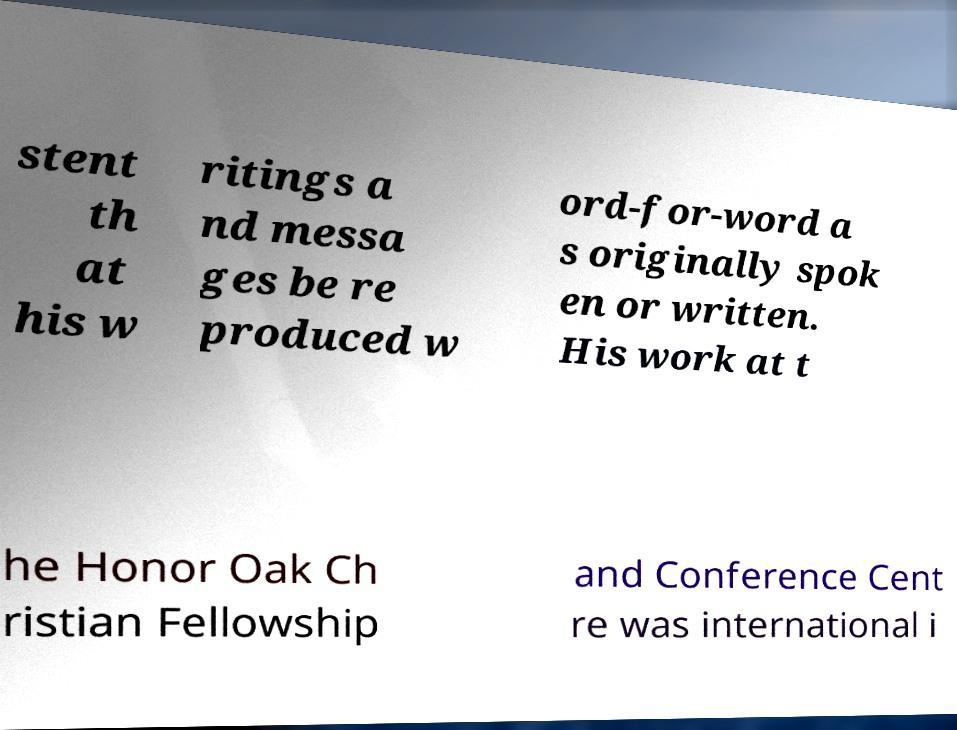There's text embedded in this image that I need extracted. Can you transcribe it verbatim? stent th at his w ritings a nd messa ges be re produced w ord-for-word a s originally spok en or written. His work at t he Honor Oak Ch ristian Fellowship and Conference Cent re was international i 